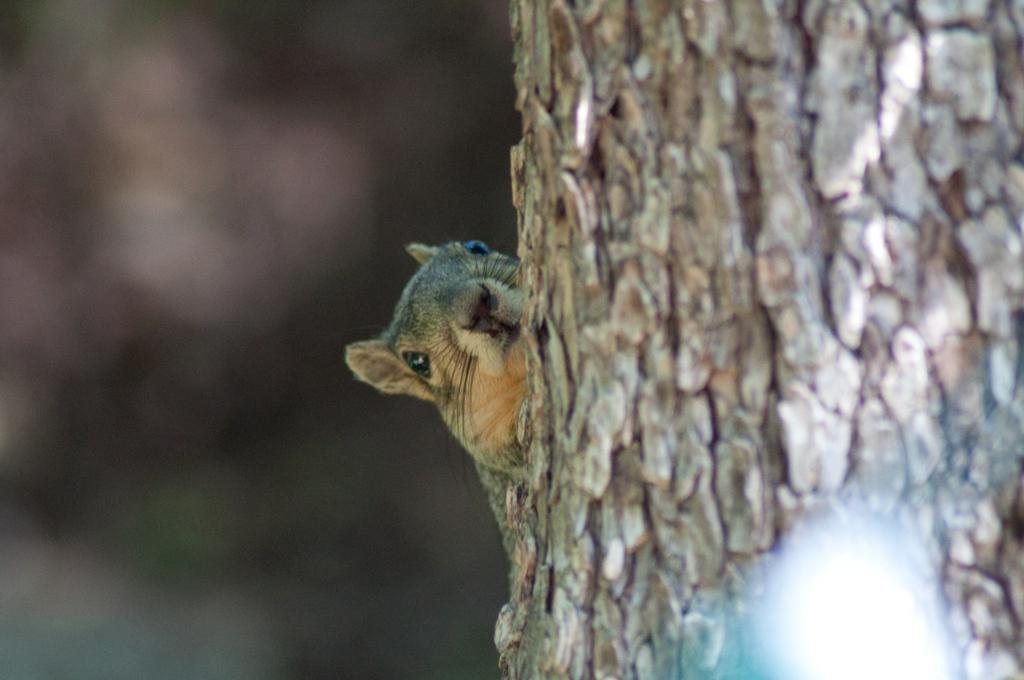What is the main object in the foreground of the image? There is a tree trunk in the image. What type of animal can be seen in the image? There is a squirrel in the image. Where is the squirrel located in relation to the tree trunk? The squirrel is in the background of the image. How clear is the image of the squirrel? The squirrel appears to be blurred in the image. What type of horn can be heard in the image? There is no horn or sound present in the image, as it is a still photograph. 